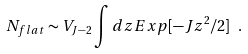<formula> <loc_0><loc_0><loc_500><loc_500>N _ { f l a t } \sim V _ { J - 2 } \int d z E x p [ - J z ^ { 2 } / 2 ] \ .</formula> 